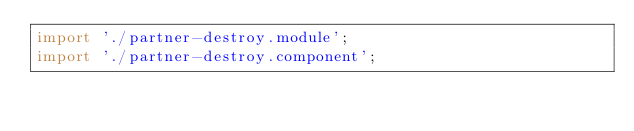<code> <loc_0><loc_0><loc_500><loc_500><_JavaScript_>import './partner-destroy.module';
import './partner-destroy.component';
</code> 